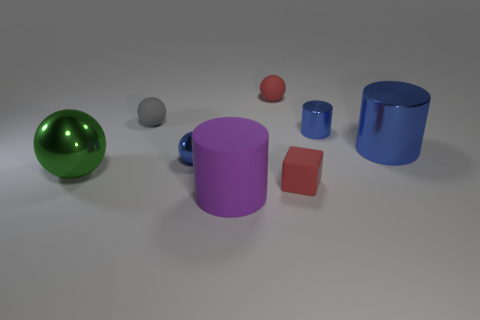How many other things are there of the same material as the green object?
Your response must be concise. 3. What number of small spheres have the same color as the large sphere?
Provide a short and direct response. 0. There is a shiny object that is to the right of the blue metal cylinder on the left side of the large metallic thing behind the tiny blue metal sphere; how big is it?
Provide a succinct answer. Large. How many rubber things are big green things or gray cylinders?
Your answer should be compact. 0. There is a large blue metal object; is it the same shape as the big thing in front of the large ball?
Your answer should be very brief. Yes. Is the number of metallic objects on the left side of the small gray ball greater than the number of red spheres in front of the big purple rubber cylinder?
Your answer should be very brief. Yes. Is there anything else that has the same color as the large metal sphere?
Ensure brevity in your answer.  No. Is there a metal sphere left of the small shiny thing on the left side of the small metal thing that is to the right of the large purple rubber object?
Make the answer very short. Yes. Do the small blue shiny object that is behind the big metallic cylinder and the big blue metallic thing have the same shape?
Keep it short and to the point. Yes. Are there fewer small red matte balls that are in front of the tiny red rubber ball than tiny gray things that are in front of the tiny blue cylinder?
Give a very brief answer. No. 